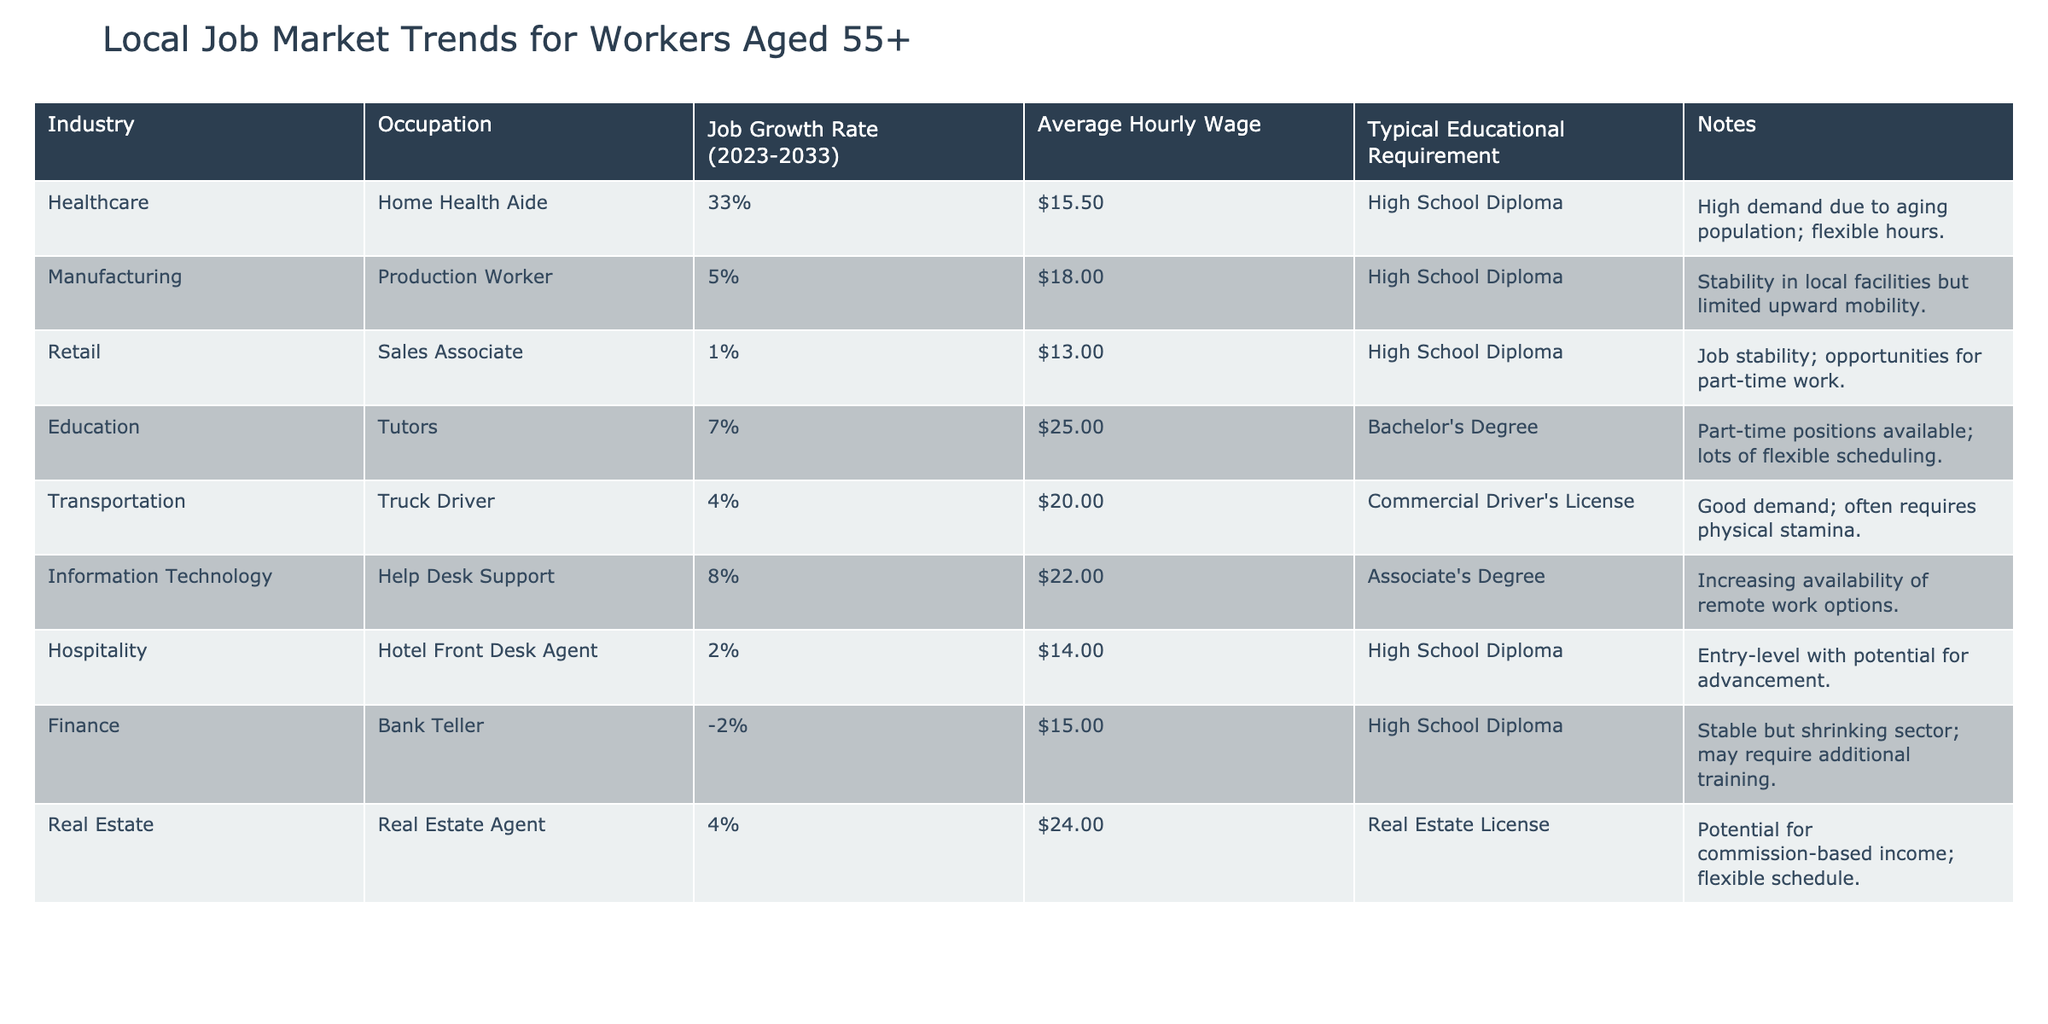What is the job growth rate for Home Health Aides? The job growth rate for Home Health Aides can be directly found in the table. It states that the growth rate is 33%.
Answer: 33% Which occupation has the highest average hourly wage? To find which occupation has the highest average hourly wage, I compare the average hourly wages listed in the table. The highest wage is $25.00 for Tutors.
Answer: $25.00 Is there a job with a negative growth rate? I check the table for any occupations that have a negative job growth rate, and I find that Bank Tellers have a growth rate of -2%, indicating a shrinking job sector.
Answer: Yes What is the average hourly wage for occupations requiring a Bachelor's Degree? From the table, the only occupation listed that requires a Bachelor's Degree is Tutors, whose average hourly wage is $25.00. As there are no other occupations in this category in the table, that's the average wage.
Answer: $25.00 Which industry has the highest job growth rate and what is that rate? I examine the job growth rates across all industries listed in the table. Home Health Aides, within the Healthcare industry, have the highest rate of 33%.
Answer: Healthcare, 33% How many occupations listed have an average hourly wage of less than $15.00? By reviewing the table, two occupations have an average hourly wage below $15.00: Home Health Aide ($15.50) and Hotel Front Desk Agent ($14.00). Hence, there is only one: the Hotel Front Desk Agent.
Answer: 1 What is the difference in average hourly wages between Production Workers and Truck Drivers? I identify the average hourly wages for Production Workers ($18.00) and Truck Drivers ($20.00) from the table. To find the difference, I deduct the wages: $20.00 - $18.00 = $2.00.
Answer: $2.00 Are there any occupations with flexible hours mentioned in the notes? I scan the table for notes indicating flexible hours. Home Health Aide and Tutors both mention flexibility, confirming there are occupations with flexible scheduling options.
Answer: Yes What percentage of the occupations listed have a growth rate of 5% or higher? I count the total number of occupations listed in the table, which is 10. Then I find those with a growth rate of 5% or more: Home Health Aide (33%), Tutors (7%), Help Desk Support (8%), and Real Estate Agent (4%). There are 4 occupations with growth rates of 5% or higher. To find the percentage: (4/10) * 100 = 40%.
Answer: 40% 